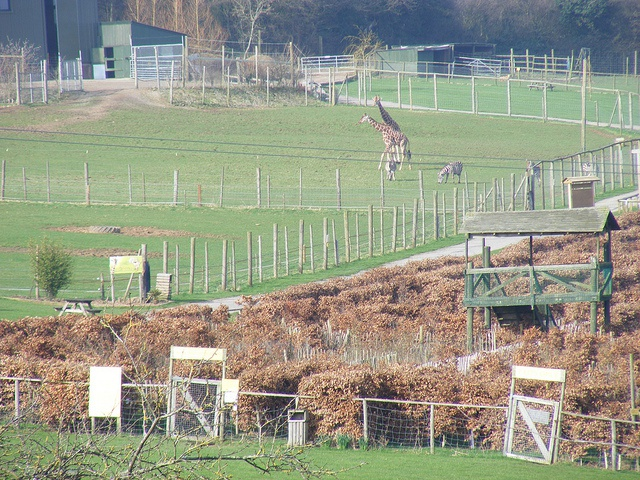Describe the objects in this image and their specific colors. I can see giraffe in gray, darkgray, and lightgray tones, giraffe in gray, darkgray, and ivory tones, and zebra in gray, darkgray, and lightgray tones in this image. 